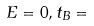Convert formula to latex. <formula><loc_0><loc_0><loc_500><loc_500>E = 0 , t _ { B } =</formula> 